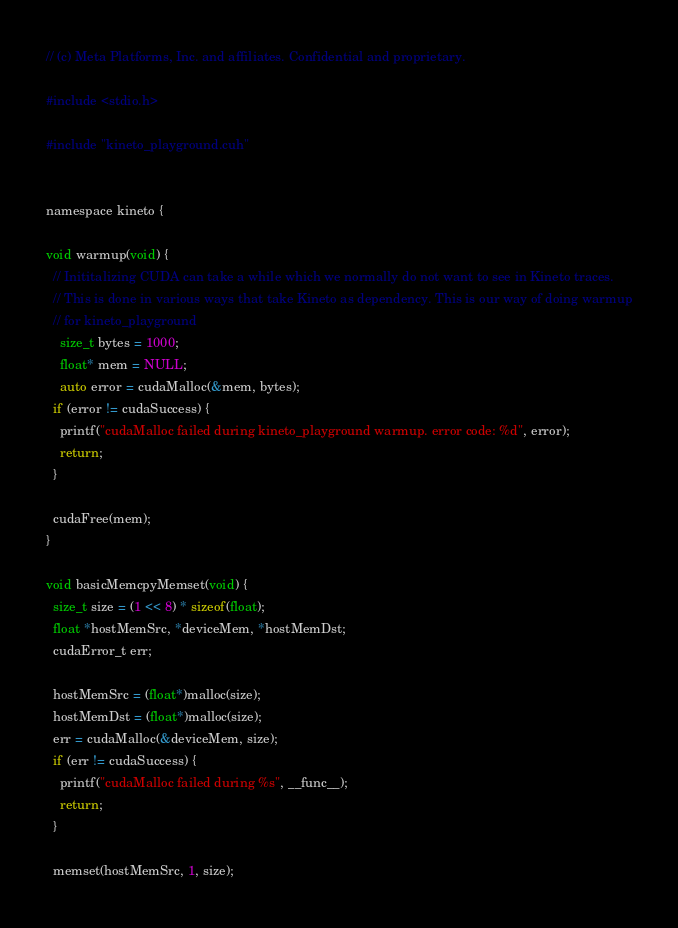<code> <loc_0><loc_0><loc_500><loc_500><_Cuda_>// (c) Meta Platforms, Inc. and affiliates. Confidential and proprietary.

#include <stdio.h>

#include "kineto_playground.cuh"


namespace kineto {

void warmup(void) {
  // Inititalizing CUDA can take a while which we normally do not want to see in Kineto traces.
  // This is done in various ways that take Kineto as dependency. This is our way of doing warmup
  // for kineto_playground
	size_t bytes = 1000;
	float* mem = NULL;
	auto error = cudaMalloc(&mem, bytes);
  if (error != cudaSuccess) {
    printf("cudaMalloc failed during kineto_playground warmup. error code: %d", error);
    return;
  }

  cudaFree(mem); 
}

void basicMemcpyMemset(void) {
  size_t size = (1 << 8) * sizeof(float);
  float *hostMemSrc, *deviceMem, *hostMemDst;
  cudaError_t err;

  hostMemSrc = (float*)malloc(size);
  hostMemDst = (float*)malloc(size);
  err = cudaMalloc(&deviceMem, size);
  if (err != cudaSuccess) {
    printf("cudaMalloc failed during %s", __func__);
    return;
  }

  memset(hostMemSrc, 1, size);</code> 